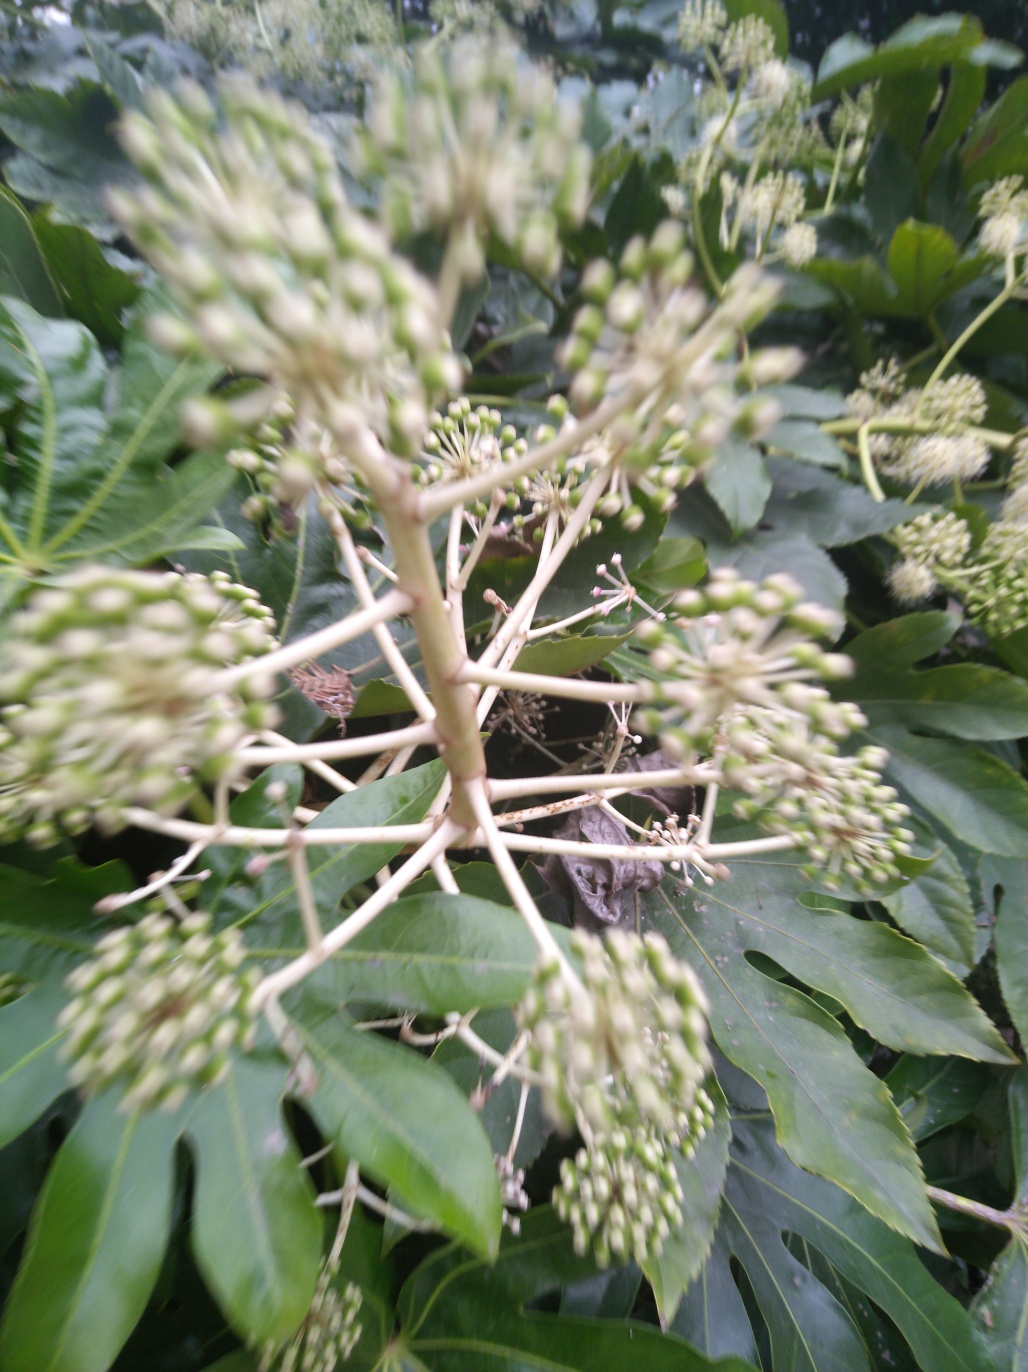What are some techniques to minimize motion blur when taking photos? To minimize motion blur, photographers can use a faster shutter speed, increase the ISO setting to allow for quicker exposures, employ a tripod to stabilize the camera, or use image stabilization features if available. For moving subjects, panning the camera at the same speed as the subject can keep it in focus while blurring the background, conveying motion without losing subject detail. 